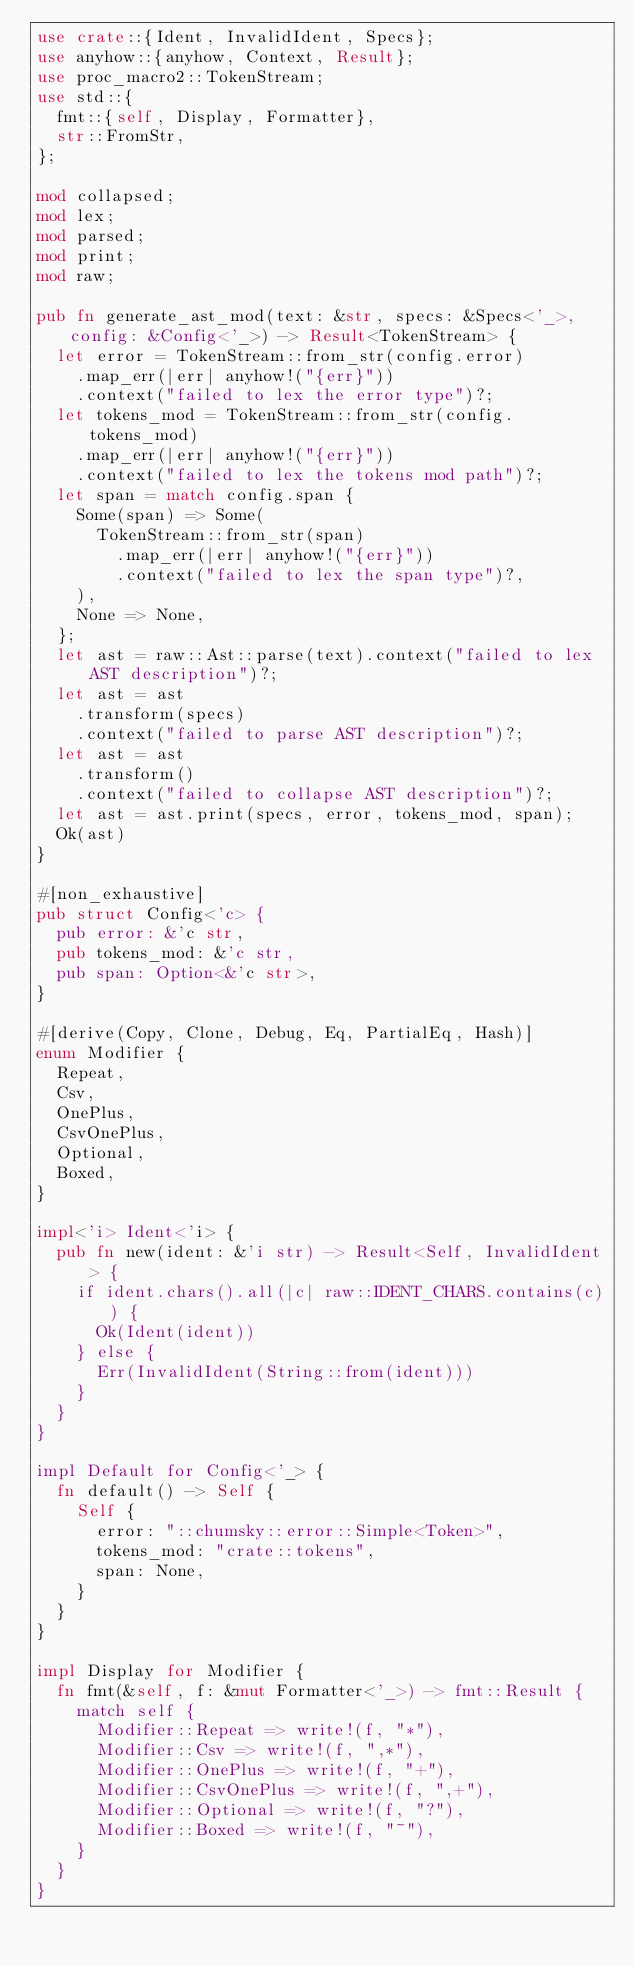<code> <loc_0><loc_0><loc_500><loc_500><_Rust_>use crate::{Ident, InvalidIdent, Specs};
use anyhow::{anyhow, Context, Result};
use proc_macro2::TokenStream;
use std::{
  fmt::{self, Display, Formatter},
  str::FromStr,
};

mod collapsed;
mod lex;
mod parsed;
mod print;
mod raw;

pub fn generate_ast_mod(text: &str, specs: &Specs<'_>, config: &Config<'_>) -> Result<TokenStream> {
  let error = TokenStream::from_str(config.error)
    .map_err(|err| anyhow!("{err}"))
    .context("failed to lex the error type")?;
  let tokens_mod = TokenStream::from_str(config.tokens_mod)
    .map_err(|err| anyhow!("{err}"))
    .context("failed to lex the tokens mod path")?;
  let span = match config.span {
    Some(span) => Some(
      TokenStream::from_str(span)
        .map_err(|err| anyhow!("{err}"))
        .context("failed to lex the span type")?,
    ),
    None => None,
  };
  let ast = raw::Ast::parse(text).context("failed to lex AST description")?;
  let ast = ast
    .transform(specs)
    .context("failed to parse AST description")?;
  let ast = ast
    .transform()
    .context("failed to collapse AST description")?;
  let ast = ast.print(specs, error, tokens_mod, span);
  Ok(ast)
}

#[non_exhaustive]
pub struct Config<'c> {
  pub error: &'c str,
  pub tokens_mod: &'c str,
  pub span: Option<&'c str>,
}

#[derive(Copy, Clone, Debug, Eq, PartialEq, Hash)]
enum Modifier {
  Repeat,
  Csv,
  OnePlus,
  CsvOnePlus,
  Optional,
  Boxed,
}

impl<'i> Ident<'i> {
  pub fn new(ident: &'i str) -> Result<Self, InvalidIdent> {
    if ident.chars().all(|c| raw::IDENT_CHARS.contains(c)) {
      Ok(Ident(ident))
    } else {
      Err(InvalidIdent(String::from(ident)))
    }
  }
}

impl Default for Config<'_> {
  fn default() -> Self {
    Self {
      error: "::chumsky::error::Simple<Token>",
      tokens_mod: "crate::tokens",
      span: None,
    }
  }
}

impl Display for Modifier {
  fn fmt(&self, f: &mut Formatter<'_>) -> fmt::Result {
    match self {
      Modifier::Repeat => write!(f, "*"),
      Modifier::Csv => write!(f, ",*"),
      Modifier::OnePlus => write!(f, "+"),
      Modifier::CsvOnePlus => write!(f, ",+"),
      Modifier::Optional => write!(f, "?"),
      Modifier::Boxed => write!(f, "~"),
    }
  }
}
</code> 